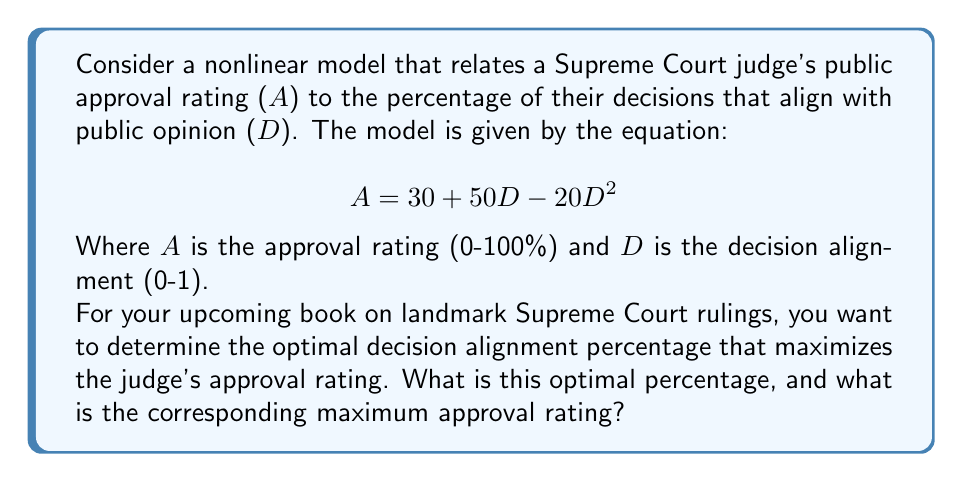Show me your answer to this math problem. To find the optimal decision alignment percentage that maximizes the judge's approval rating, we need to follow these steps:

1) The given equation represents a quadratic function:
   $$A = 30 + 50D - 20D^2$$

2) To find the maximum of a quadratic function, we need to find the vertex. The x-coordinate of the vertex will give us the optimal decision alignment percentage (D), and the y-coordinate will give us the maximum approval rating (A).

3) For a quadratic function in the form $f(x) = ax^2 + bx + c$, the x-coordinate of the vertex is given by $x = -\frac{b}{2a}$.

4) In our case, $a = -20$, $b = 50$, and $c = 30$. Let's substitute these values:

   $$D = -\frac{50}{2(-20)} = -\frac{50}{-40} = \frac{5}{4} = 1.25$$

5) However, since D represents a percentage and can't exceed 1 (100%), we need to limit our result to 1.

6) To find the maximum approval rating, we substitute D = 1 into our original equation:

   $$A = 30 + 50(1) - 20(1)^2 = 30 + 50 - 20 = 60$$

7) Therefore, the optimal decision alignment percentage is 100%, and the corresponding maximum approval rating is 60%.
Answer: Optimal decision alignment: 100%, Maximum approval rating: 60% 